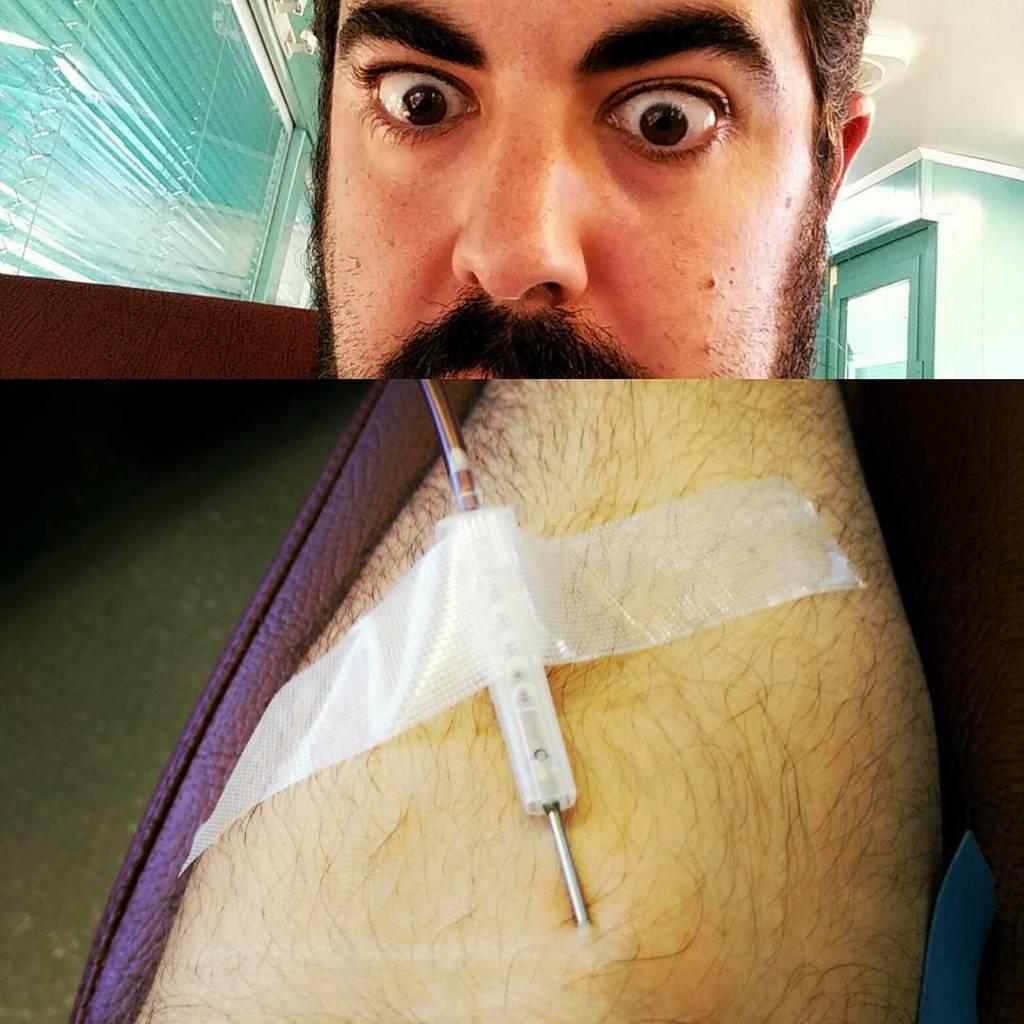How would you summarize this image in a sentence or two? In this image we can see collage of pictures. one person and a needle on a hand stick with a tape. in the background ,we can see group of windows and door. 